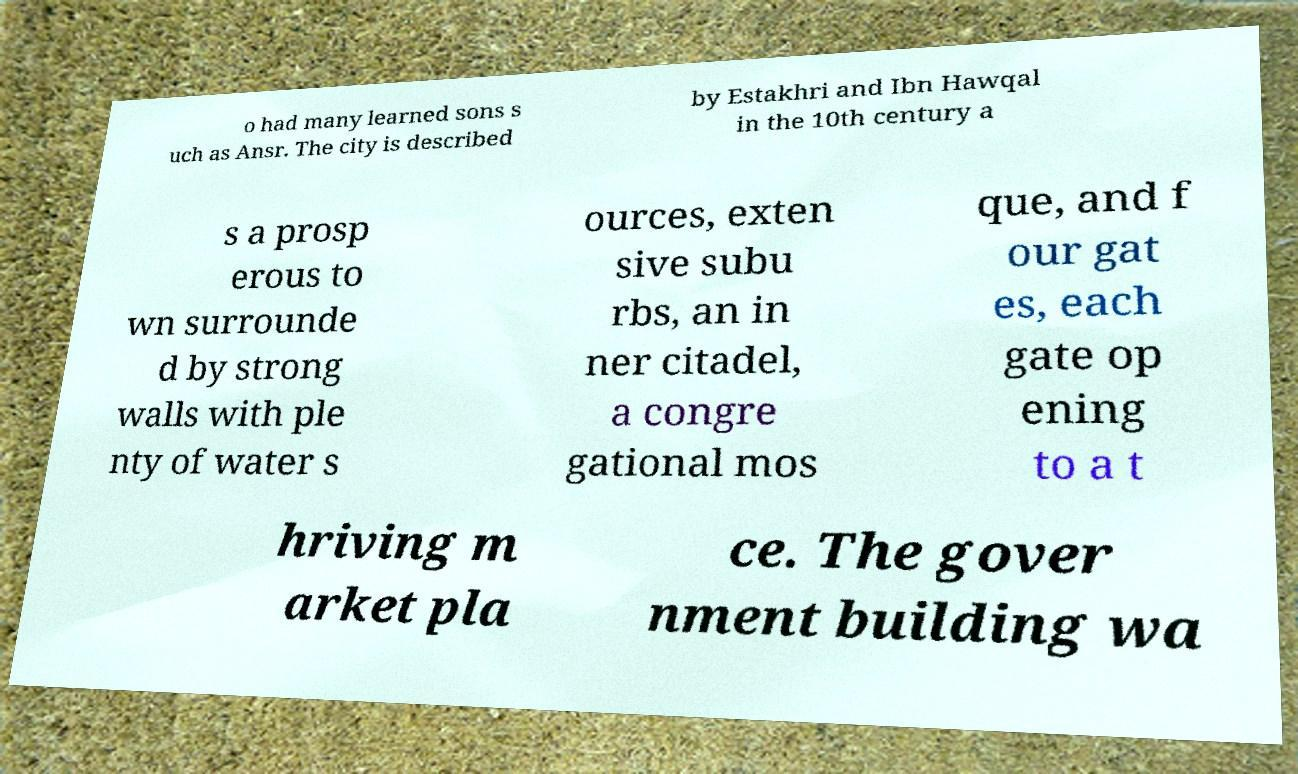I need the written content from this picture converted into text. Can you do that? o had many learned sons s uch as Ansr. The city is described by Estakhri and Ibn Hawqal in the 10th century a s a prosp erous to wn surrounde d by strong walls with ple nty of water s ources, exten sive subu rbs, an in ner citadel, a congre gational mos que, and f our gat es, each gate op ening to a t hriving m arket pla ce. The gover nment building wa 